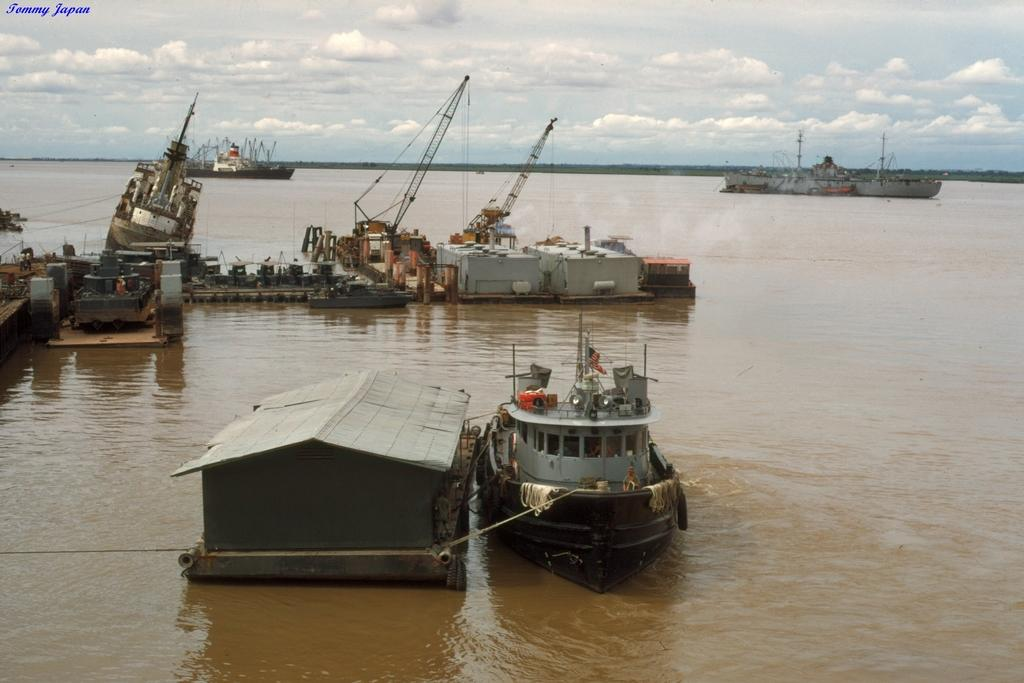What type of vehicles are in the image? There are ships in the image. What type of structures are in the image? There are huts in the image. What is the setting for the ships and huts? The ships and huts are sailing on water. What is visible in the background of the image? The sky is visible in the image. What is the weather like in the image? The sky is cloudy in the image. What type of ring can be seen on the hut in the image? There is no ring present on the hut in the image. What does the calendar on the ship indicate about the date? There is no calendar present on the ship in the image. 